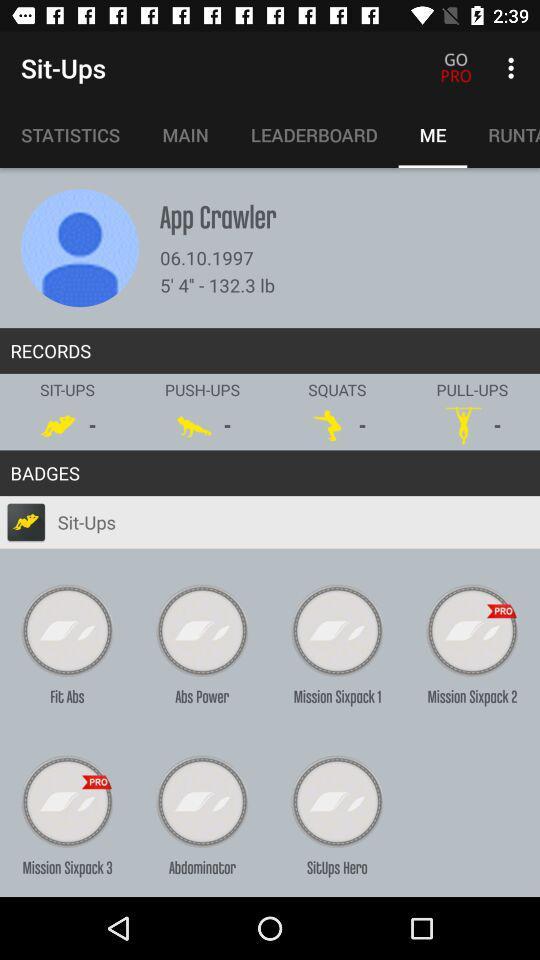What is the user name? The user name is App Crawler. 